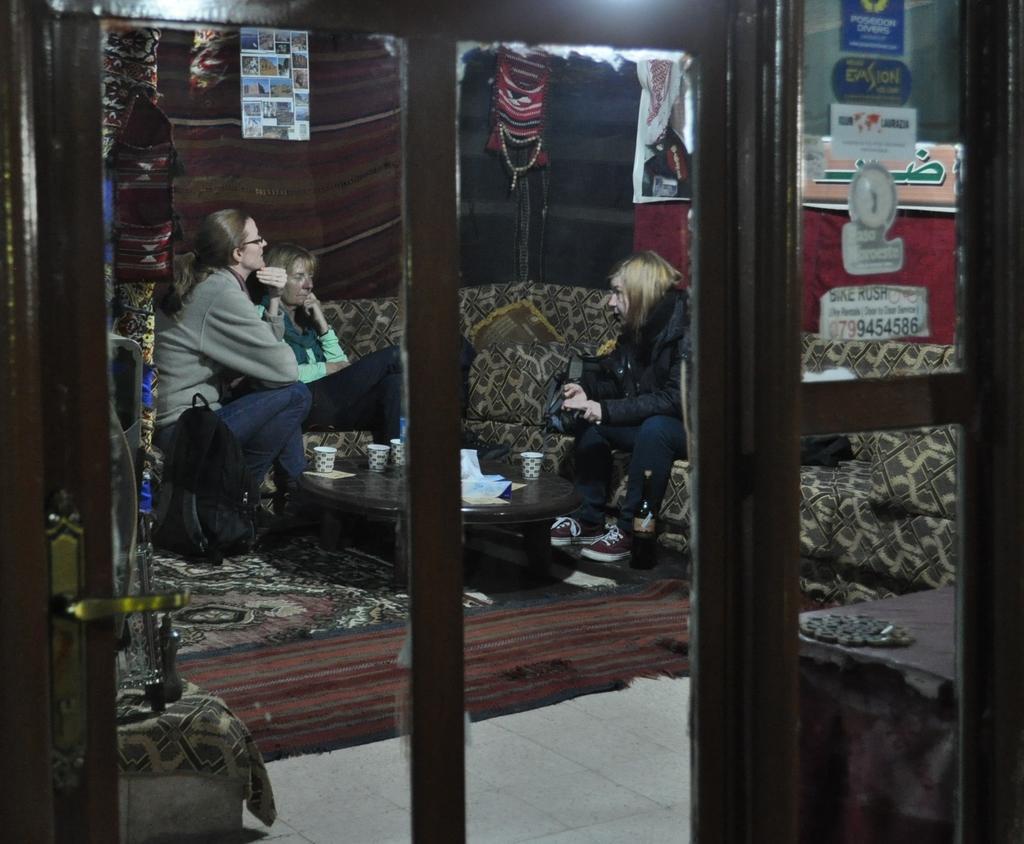In one or two sentences, can you explain what this image depicts? In the foreground there is a glass door through which we can see the inside view of a room. Inside the room there are three persons sitting on a couch. In front of these people there is a table on which few glasses and some other objects are placed. On the floor there is a mat. On the right side there is a table. In the background there are few posts attached to the wall and there is a curtain. 